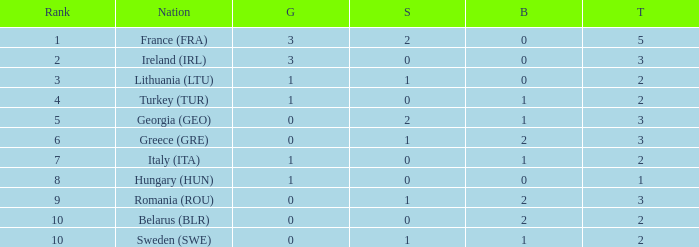What's the total when the gold is less than 0 and silver is less than 1? None. 